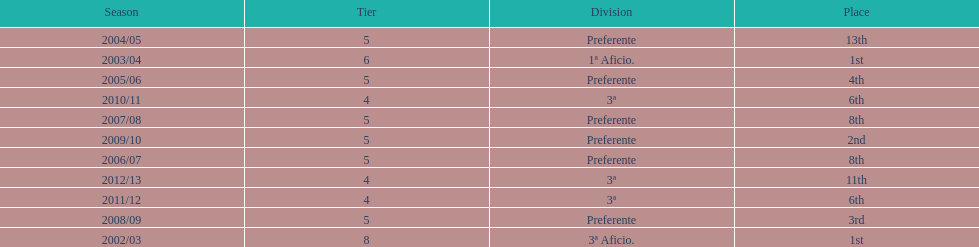How long did the team stay in first place? 2 years. 